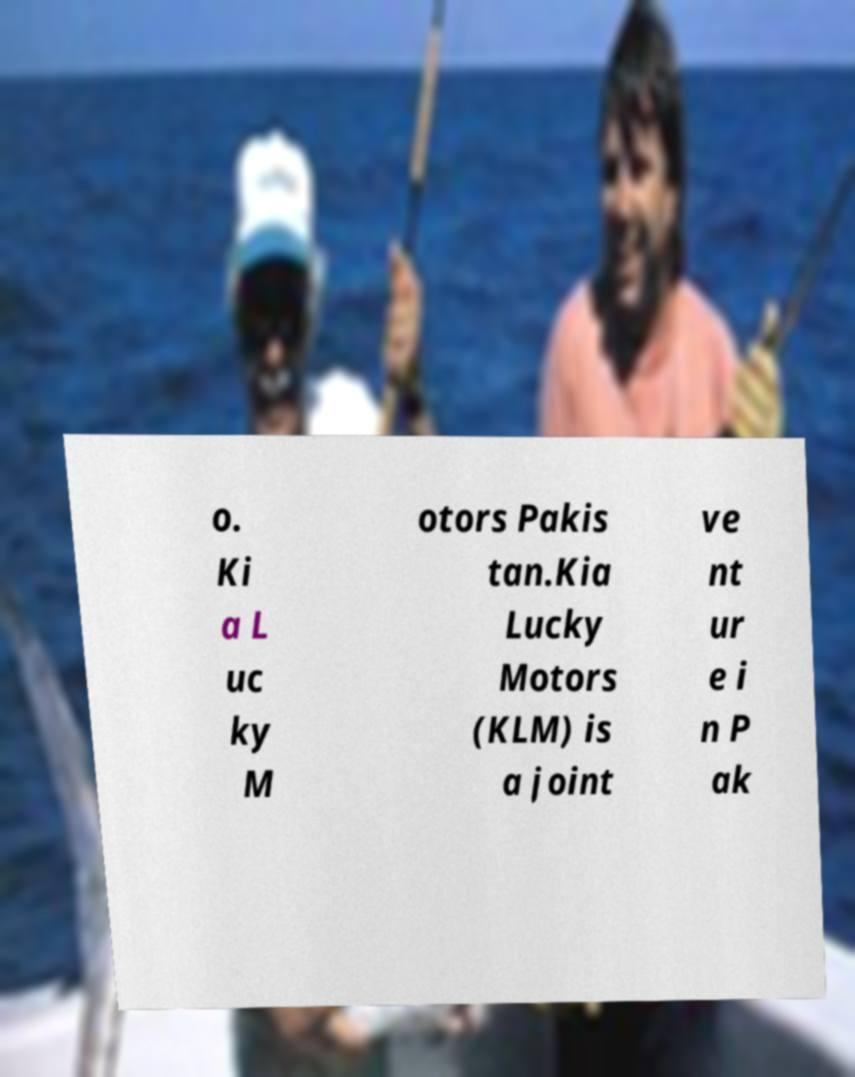Could you assist in decoding the text presented in this image and type it out clearly? o. Ki a L uc ky M otors Pakis tan.Kia Lucky Motors (KLM) is a joint ve nt ur e i n P ak 